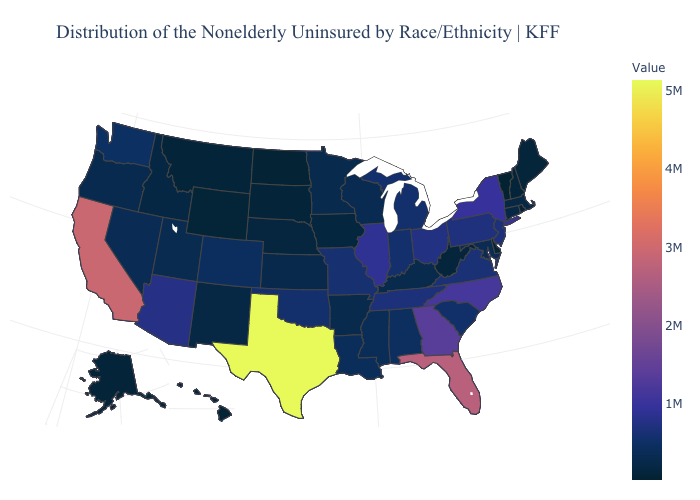Does Delaware have the lowest value in the South?
Write a very short answer. Yes. Does Texas have the highest value in the USA?
Write a very short answer. Yes. Does Washington have a higher value than Florida?
Answer briefly. No. Which states have the lowest value in the USA?
Concise answer only. Vermont. Does New York have the highest value in the Northeast?
Answer briefly. Yes. Is the legend a continuous bar?
Be succinct. Yes. 